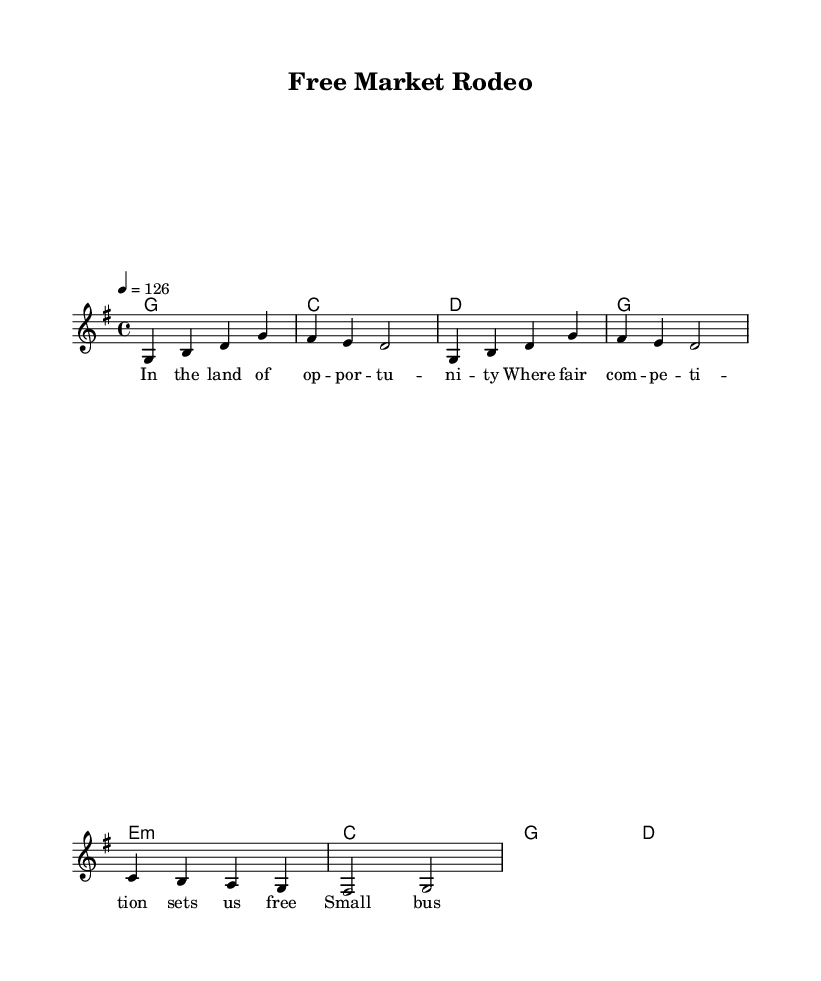What is the key signature of this music? The key signature is G major, indicated by one sharp (F#) at the beginning of the staff.
Answer: G major What is the time signature of this music? The time signature is 4/4, which is shown at the beginning and indicates four beats per measure.
Answer: 4/4 What is the tempo marking of this music? The tempo marking indicates a speed of 126 beats per minute, shown as "4 = 126" in the score.
Answer: 126 What notes make up the first measure of the melody? The first measure contains the notes G, B, D, and G, as represented in the melody staff.
Answer: G, B, D, G What chords are used in the harmonies section? The chords listed in the chord section include G, C, D, e minor, and back to G.
Answer: G, C, D, e minor Explain how the melody relates to the chords in the first line. The melody begins on the note G, which corresponds to the G major chord in the harmony. The subsequent notes in the melody also align with the chord tones of C and D in the following measures, suggesting a strong connection between the melody and its underlying harmonies.
Answer: Melody and chords align harmonically What theme does the lyrics convey about business values? The lyrics celebrate opportunity and competition, emphasizing how small business dreams thrive in such an environment, reflecting traditional American values.
Answer: Opportunity and fair competition 